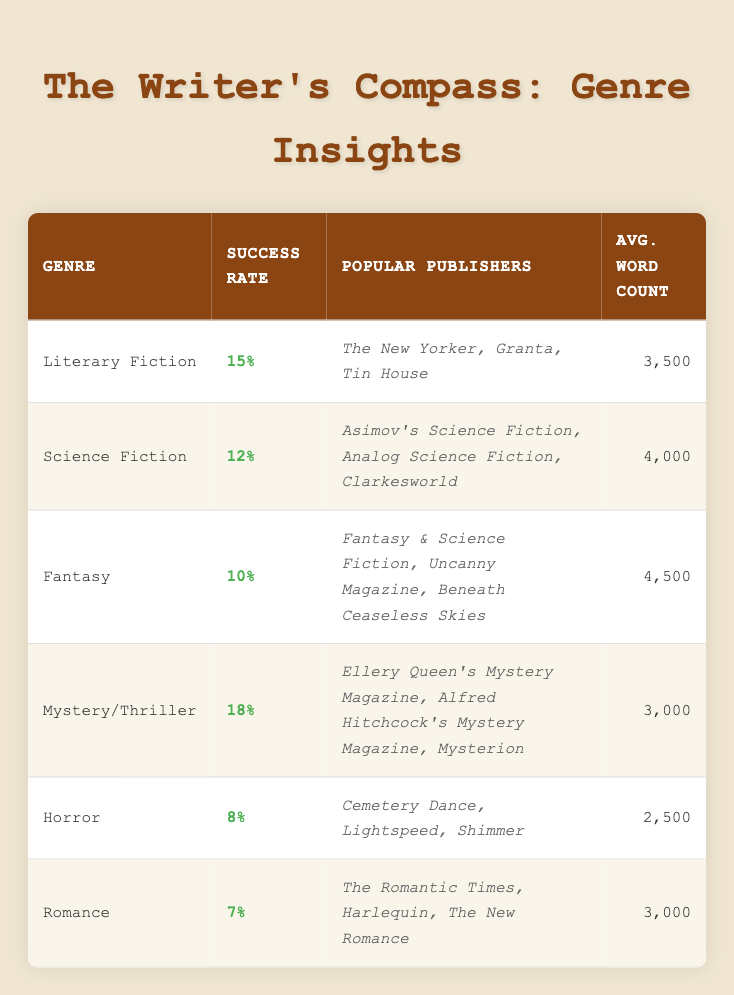What is the submission success rate for Literary Fiction? The table shows that the submission success rate for Literary Fiction is 15%.
Answer: 15% Which genre has the highest submission success rate? The table indicates that Mystery/Thriller has the highest submission success rate at 18%.
Answer: Mystery/Thriller What is the average word count for Fantasy stories? According to the table, the average word count for Fantasy stories is 4,500 words.
Answer: 4,500 How many genres have a submission success rate of less than 10%? By examining the table, Horror (8%) and Romance (7%) are the only two genres with a submission success rate below 10%. Therefore, there are 2 genres.
Answer: 2 If you combined the average word counts of Literary Fiction and Science Fiction, what would that total be? The average word count for Literary Fiction is 3,500, and for Science Fiction, it is 4,000. Combining these gives 3,500 + 4,000 = 7,500 words.
Answer: 7,500 Is it true that all genres listed have an average word count greater than 2,000 words? Checking the table, all listed genres have average word counts greater than 2,000 (the lowest being Horror at 2,500). Therefore, the statement is true.
Answer: True What is the difference in submission success rates between Mystery/Thriller and Romance? The submission success rate for Mystery/Thriller is 18%, and for Romance, it is 7%. The difference is 18 - 7 = 11%.
Answer: 11% Name one popular publisher for the Sci-Fi genre. The table lists Asimov's Science Fiction, Analog Science Fiction, and Clarkesworld as popular publishers for the Science Fiction genre. One of them is Asimov's Science Fiction.
Answer: Asimov's Science Fiction How many genres have a submission success rate of 10% or higher? The genres with a success rate of 10% or higher are Literary Fiction (15%), Science Fiction (12%), Fantasy (10%), and Mystery/Thriller (18%). This totals to 4 genres.
Answer: 4 